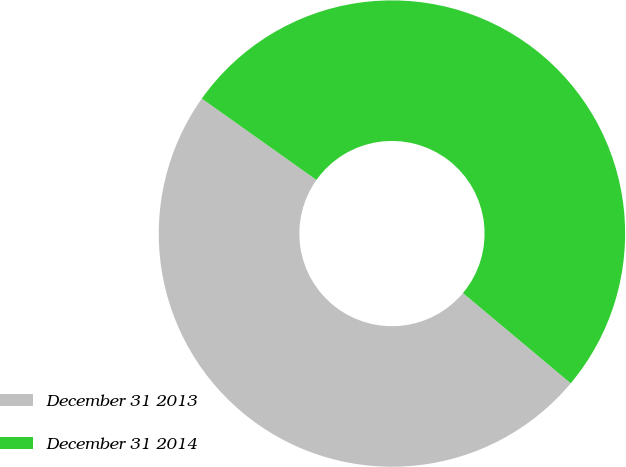<chart> <loc_0><loc_0><loc_500><loc_500><pie_chart><fcel>December 31 2013<fcel>December 31 2014<nl><fcel>48.73%<fcel>51.27%<nl></chart> 